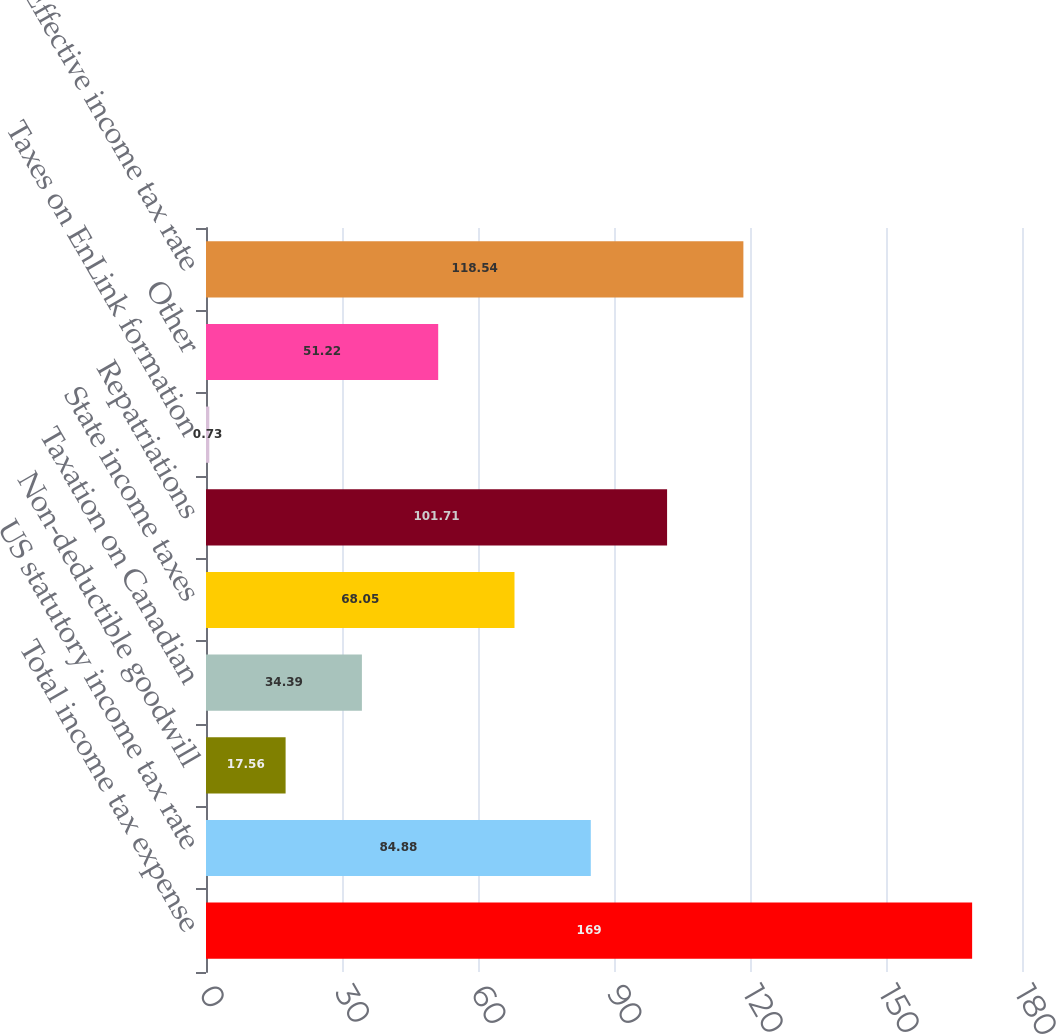Convert chart. <chart><loc_0><loc_0><loc_500><loc_500><bar_chart><fcel>Total income tax expense<fcel>US statutory income tax rate<fcel>Non-deductible goodwill<fcel>Taxation on Canadian<fcel>State income taxes<fcel>Repatriations<fcel>Taxes on EnLink formation<fcel>Other<fcel>Effective income tax rate<nl><fcel>169<fcel>84.88<fcel>17.56<fcel>34.39<fcel>68.05<fcel>101.71<fcel>0.73<fcel>51.22<fcel>118.54<nl></chart> 